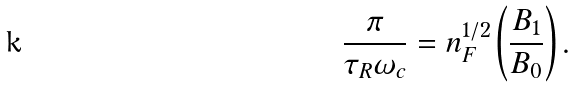Convert formula to latex. <formula><loc_0><loc_0><loc_500><loc_500>\frac { \pi } { \tau _ { R } \omega _ { c } } = n _ { F } ^ { 1 / 2 } \left ( \frac { B _ { 1 } } { B _ { 0 } } \right ) .</formula> 